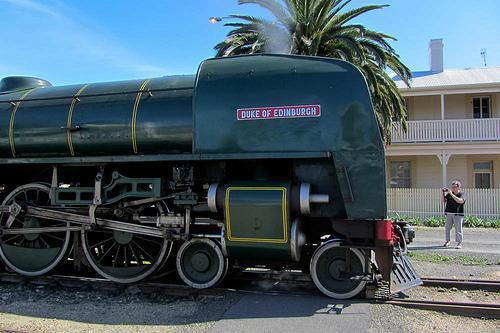How many people are shown?
Give a very brief answer. 1. 